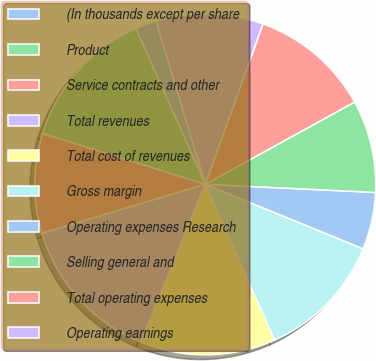Convert chart to OTSL. <chart><loc_0><loc_0><loc_500><loc_500><pie_chart><fcel>(In thousands except per share<fcel>Product<fcel>Service contracts and other<fcel>Total revenues<fcel>Total cost of revenues<fcel>Gross margin<fcel>Operating expenses Research<fcel>Selling general and<fcel>Total operating expenses<fcel>Operating earnings<nl><fcel>2.03%<fcel>13.51%<fcel>9.46%<fcel>14.19%<fcel>12.84%<fcel>12.16%<fcel>5.41%<fcel>8.78%<fcel>11.49%<fcel>10.14%<nl></chart> 